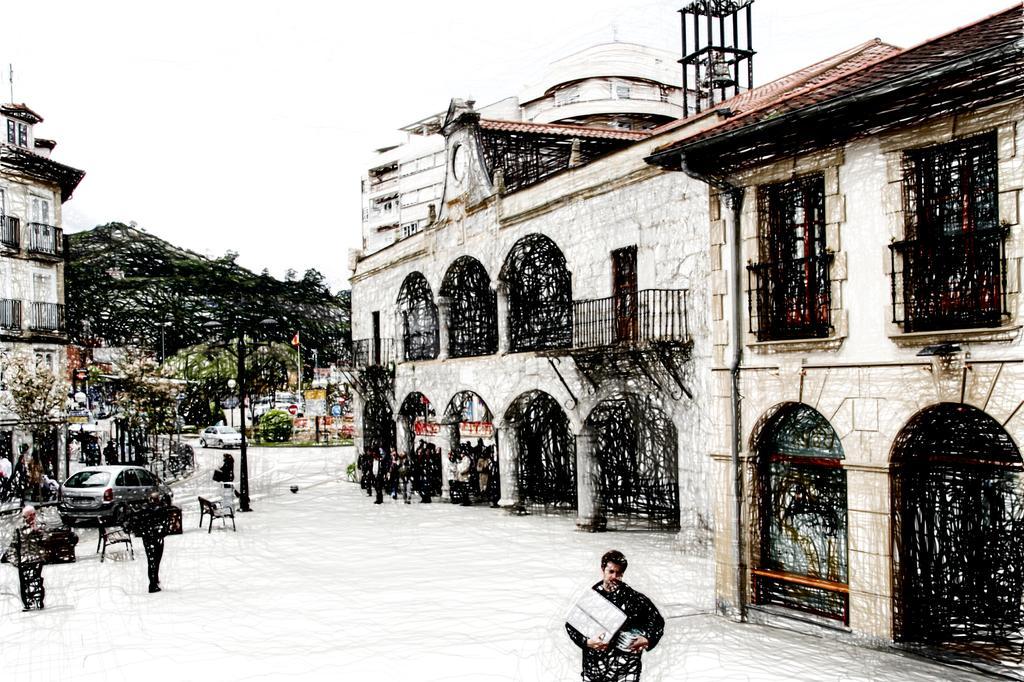Describe this image in one or two sentences. In the picture I can see the snowfall, I can see people walking on the road, vehicles moving on the road, I can see poles, flags, buildings, trees and the sky in the background. 